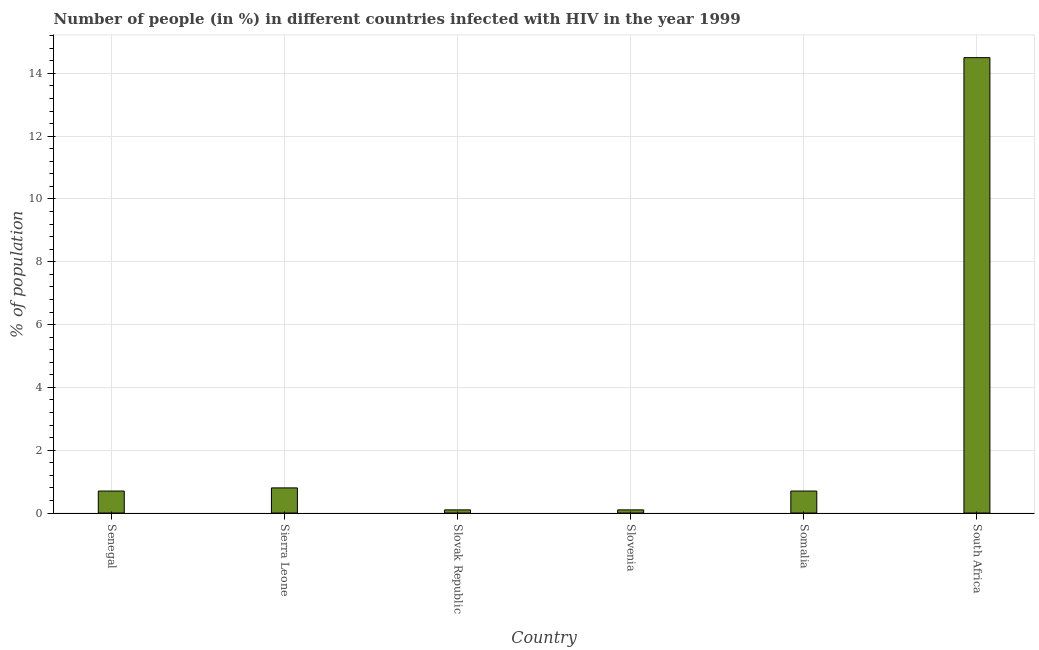Does the graph contain grids?
Your answer should be compact. Yes. What is the title of the graph?
Ensure brevity in your answer.  Number of people (in %) in different countries infected with HIV in the year 1999. What is the label or title of the X-axis?
Make the answer very short. Country. What is the label or title of the Y-axis?
Offer a very short reply. % of population. What is the number of people infected with hiv in Sierra Leone?
Ensure brevity in your answer.  0.8. Across all countries, what is the maximum number of people infected with hiv?
Keep it short and to the point. 14.5. Across all countries, what is the minimum number of people infected with hiv?
Give a very brief answer. 0.1. In which country was the number of people infected with hiv maximum?
Provide a succinct answer. South Africa. In which country was the number of people infected with hiv minimum?
Your answer should be very brief. Slovak Republic. What is the average number of people infected with hiv per country?
Provide a short and direct response. 2.82. What is the median number of people infected with hiv?
Your response must be concise. 0.7. What is the ratio of the number of people infected with hiv in Sierra Leone to that in Somalia?
Provide a short and direct response. 1.14. Is the number of people infected with hiv in Senegal less than that in South Africa?
Offer a terse response. Yes. Is the difference between the number of people infected with hiv in Sierra Leone and Somalia greater than the difference between any two countries?
Your answer should be very brief. No. Is the sum of the number of people infected with hiv in Sierra Leone and Slovak Republic greater than the maximum number of people infected with hiv across all countries?
Your answer should be very brief. No. What is the difference between the highest and the lowest number of people infected with hiv?
Ensure brevity in your answer.  14.4. In how many countries, is the number of people infected with hiv greater than the average number of people infected with hiv taken over all countries?
Keep it short and to the point. 1. Are all the bars in the graph horizontal?
Your answer should be compact. No. How many countries are there in the graph?
Your answer should be very brief. 6. What is the difference between two consecutive major ticks on the Y-axis?
Ensure brevity in your answer.  2. Are the values on the major ticks of Y-axis written in scientific E-notation?
Offer a very short reply. No. What is the % of population in Senegal?
Your response must be concise. 0.7. What is the % of population of Sierra Leone?
Make the answer very short. 0.8. What is the % of population of Slovenia?
Provide a short and direct response. 0.1. What is the % of population of Somalia?
Provide a succinct answer. 0.7. What is the % of population in South Africa?
Give a very brief answer. 14.5. What is the difference between the % of population in Senegal and Somalia?
Provide a succinct answer. 0. What is the difference between the % of population in Senegal and South Africa?
Your response must be concise. -13.8. What is the difference between the % of population in Sierra Leone and Slovenia?
Give a very brief answer. 0.7. What is the difference between the % of population in Sierra Leone and Somalia?
Your answer should be compact. 0.1. What is the difference between the % of population in Sierra Leone and South Africa?
Keep it short and to the point. -13.7. What is the difference between the % of population in Slovak Republic and Slovenia?
Make the answer very short. 0. What is the difference between the % of population in Slovak Republic and Somalia?
Give a very brief answer. -0.6. What is the difference between the % of population in Slovak Republic and South Africa?
Offer a terse response. -14.4. What is the difference between the % of population in Slovenia and South Africa?
Your answer should be very brief. -14.4. What is the difference between the % of population in Somalia and South Africa?
Your response must be concise. -13.8. What is the ratio of the % of population in Senegal to that in Slovak Republic?
Your answer should be compact. 7. What is the ratio of the % of population in Senegal to that in Slovenia?
Give a very brief answer. 7. What is the ratio of the % of population in Senegal to that in Somalia?
Offer a terse response. 1. What is the ratio of the % of population in Senegal to that in South Africa?
Provide a succinct answer. 0.05. What is the ratio of the % of population in Sierra Leone to that in Slovenia?
Your answer should be compact. 8. What is the ratio of the % of population in Sierra Leone to that in Somalia?
Ensure brevity in your answer.  1.14. What is the ratio of the % of population in Sierra Leone to that in South Africa?
Give a very brief answer. 0.06. What is the ratio of the % of population in Slovak Republic to that in Slovenia?
Offer a very short reply. 1. What is the ratio of the % of population in Slovak Republic to that in Somalia?
Give a very brief answer. 0.14. What is the ratio of the % of population in Slovak Republic to that in South Africa?
Ensure brevity in your answer.  0.01. What is the ratio of the % of population in Slovenia to that in Somalia?
Keep it short and to the point. 0.14. What is the ratio of the % of population in Slovenia to that in South Africa?
Your response must be concise. 0.01. What is the ratio of the % of population in Somalia to that in South Africa?
Keep it short and to the point. 0.05. 